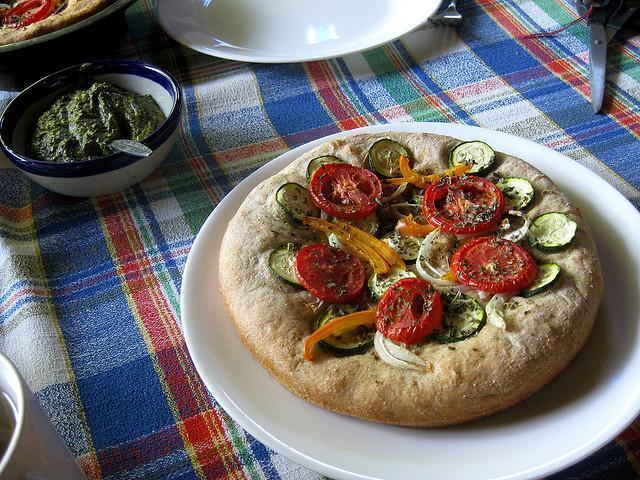How many bowls are there?
Give a very brief answer. 1. 